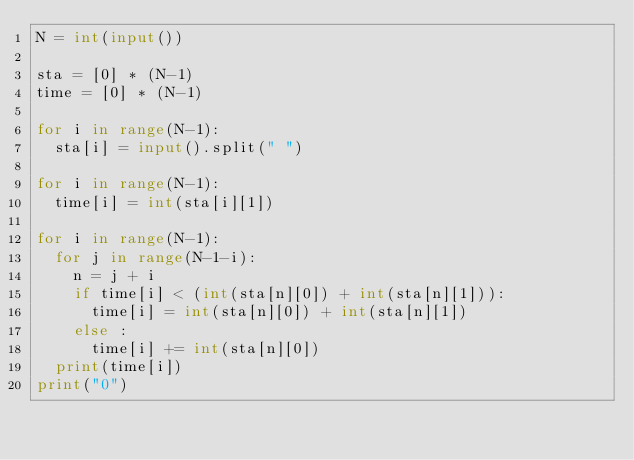<code> <loc_0><loc_0><loc_500><loc_500><_Python_>N = int(input())

sta = [0] * (N-1)
time = [0] * (N-1)

for i in range(N-1):
  sta[i] = input().split(" ")

for i in range(N-1):
  time[i] = int(sta[i][1])

for i in range(N-1):
  for j in range(N-1-i):
    n = j + i
    if time[i] < (int(sta[n][0]) + int(sta[n][1])):
      time[i] = int(sta[n][0]) + int(sta[n][1])
    else :
      time[i] += int(sta[n][0])
  print(time[i])
print("0")</code> 